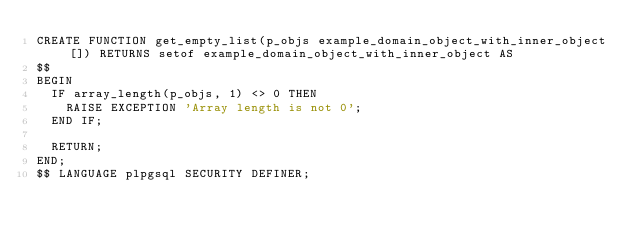<code> <loc_0><loc_0><loc_500><loc_500><_SQL_>CREATE FUNCTION get_empty_list(p_objs example_domain_object_with_inner_object[]) RETURNS setof example_domain_object_with_inner_object AS
$$
BEGIN
  IF array_length(p_objs, 1) <> 0 THEN
    RAISE EXCEPTION 'Array length is not 0';
  END IF;

  RETURN;
END;
$$ LANGUAGE plpgsql SECURITY DEFINER;
</code> 